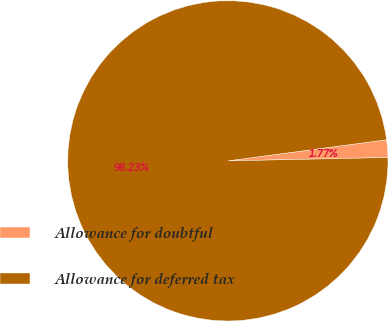Convert chart. <chart><loc_0><loc_0><loc_500><loc_500><pie_chart><fcel>Allowance for doubtful<fcel>Allowance for deferred tax<nl><fcel>1.77%<fcel>98.23%<nl></chart> 